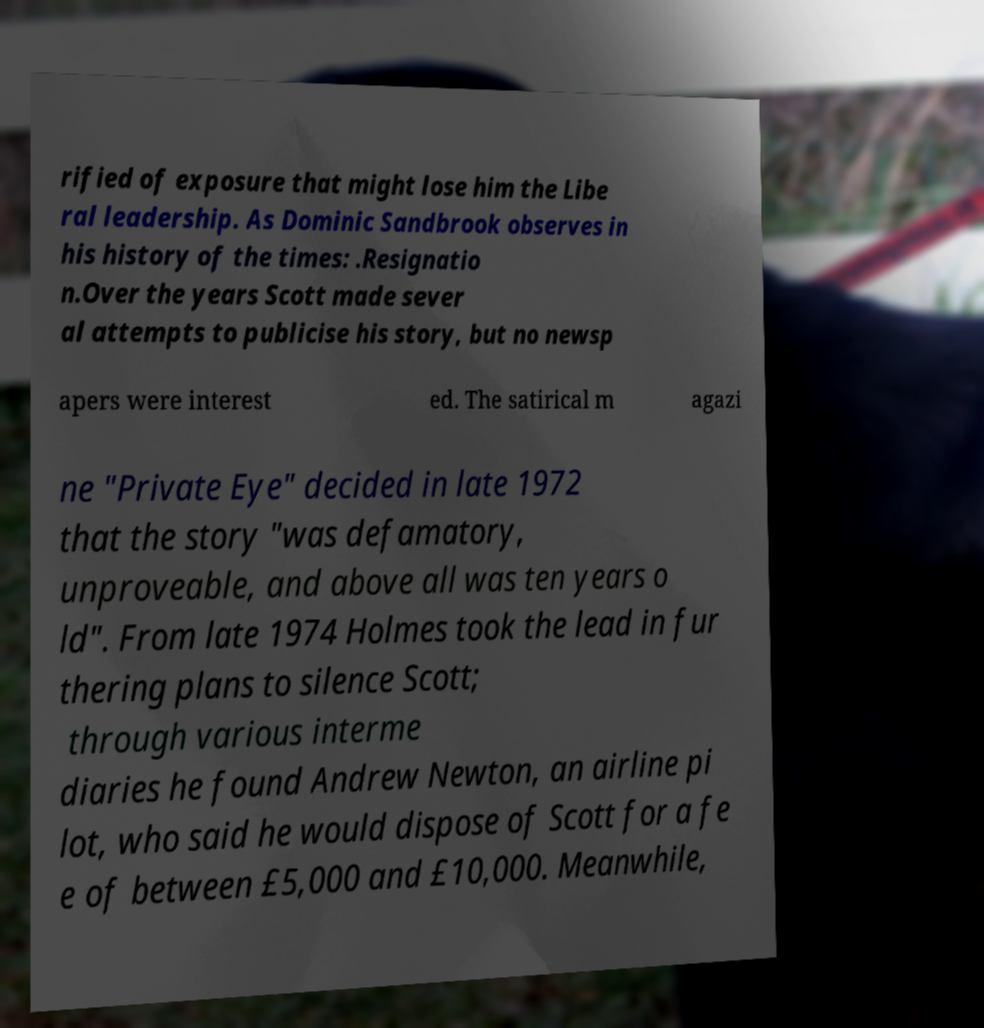Can you read and provide the text displayed in the image?This photo seems to have some interesting text. Can you extract and type it out for me? rified of exposure that might lose him the Libe ral leadership. As Dominic Sandbrook observes in his history of the times: .Resignatio n.Over the years Scott made sever al attempts to publicise his story, but no newsp apers were interest ed. The satirical m agazi ne "Private Eye" decided in late 1972 that the story "was defamatory, unproveable, and above all was ten years o ld". From late 1974 Holmes took the lead in fur thering plans to silence Scott; through various interme diaries he found Andrew Newton, an airline pi lot, who said he would dispose of Scott for a fe e of between £5,000 and £10,000. Meanwhile, 